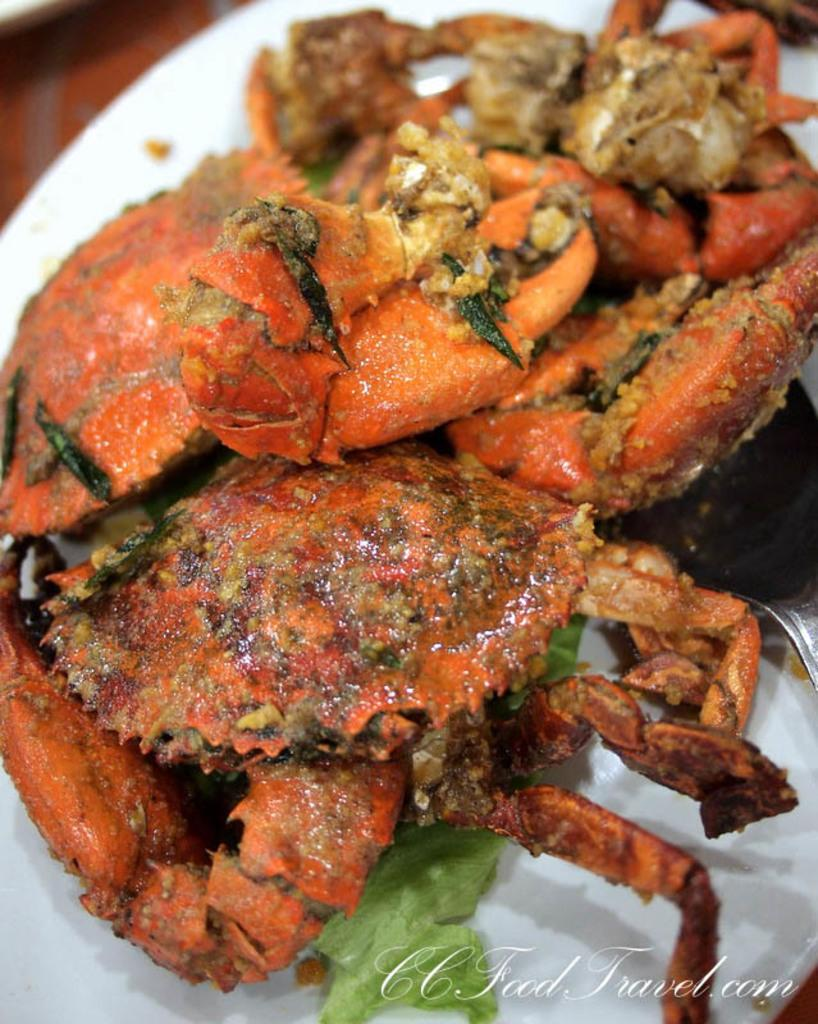What type of seafood is visible in the image? There is a cooked crab in the image. How is the cooked crab presented in the image? The cooked crab is served on a white plate. What type of chalk is used to draw on the wall in the image? There is no chalk or wall present in the image; it only features a cooked crab on a white plate. 